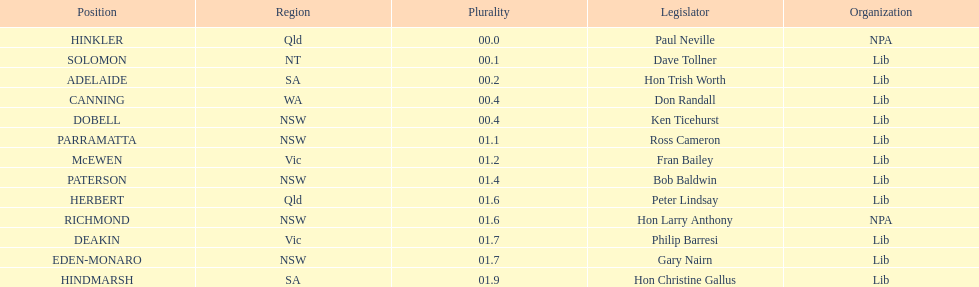What is the difference in majority between hindmarsh and hinkler? 01.9. Would you mind parsing the complete table? {'header': ['Position', 'Region', 'Plurality', 'Legislator', 'Organization'], 'rows': [['HINKLER', 'Qld', '00.0', 'Paul Neville', 'NPA'], ['SOLOMON', 'NT', '00.1', 'Dave Tollner', 'Lib'], ['ADELAIDE', 'SA', '00.2', 'Hon Trish Worth', 'Lib'], ['CANNING', 'WA', '00.4', 'Don Randall', 'Lib'], ['DOBELL', 'NSW', '00.4', 'Ken Ticehurst', 'Lib'], ['PARRAMATTA', 'NSW', '01.1', 'Ross Cameron', 'Lib'], ['McEWEN', 'Vic', '01.2', 'Fran Bailey', 'Lib'], ['PATERSON', 'NSW', '01.4', 'Bob Baldwin', 'Lib'], ['HERBERT', 'Qld', '01.6', 'Peter Lindsay', 'Lib'], ['RICHMOND', 'NSW', '01.6', 'Hon Larry Anthony', 'NPA'], ['DEAKIN', 'Vic', '01.7', 'Philip Barresi', 'Lib'], ['EDEN-MONARO', 'NSW', '01.7', 'Gary Nairn', 'Lib'], ['HINDMARSH', 'SA', '01.9', 'Hon Christine Gallus', 'Lib']]} 